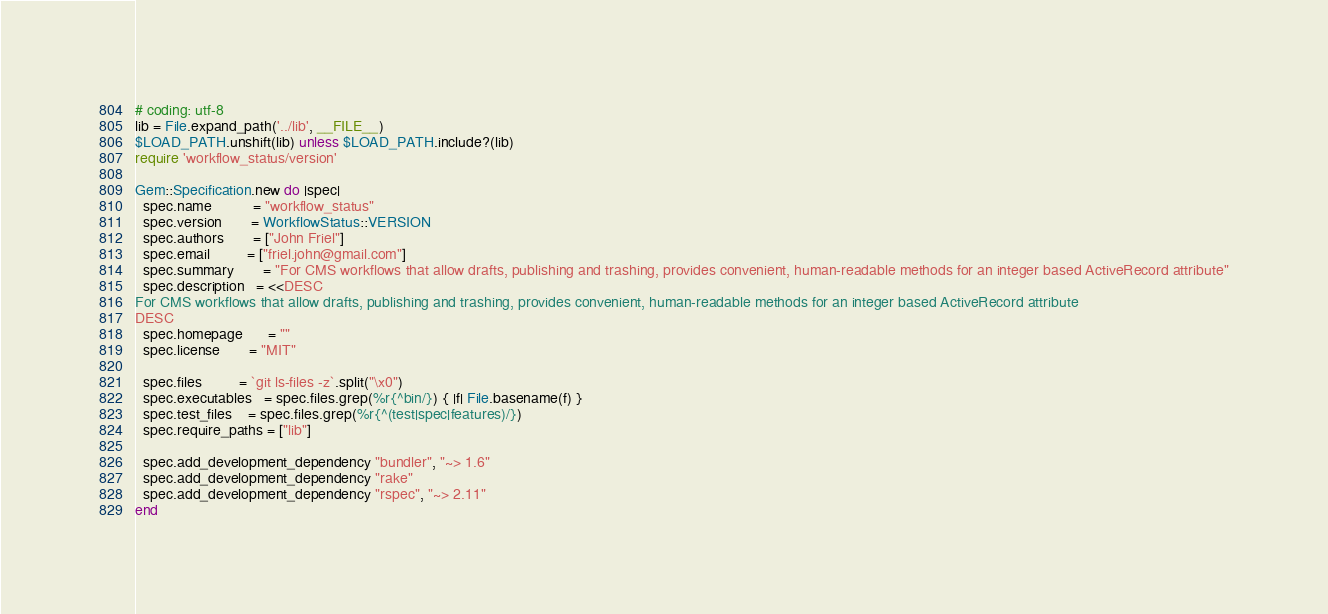<code> <loc_0><loc_0><loc_500><loc_500><_Ruby_># coding: utf-8
lib = File.expand_path('../lib', __FILE__)
$LOAD_PATH.unshift(lib) unless $LOAD_PATH.include?(lib)
require 'workflow_status/version'

Gem::Specification.new do |spec|
  spec.name          = "workflow_status"
  spec.version       = WorkflowStatus::VERSION
  spec.authors       = ["John Friel"]
  spec.email         = ["friel.john@gmail.com"]
  spec.summary       = "For CMS workflows that allow drafts, publishing and trashing, provides convenient, human-readable methods for an integer based ActiveRecord attribute"
  spec.description   = <<DESC
For CMS workflows that allow drafts, publishing and trashing, provides convenient, human-readable methods for an integer based ActiveRecord attribute
DESC
  spec.homepage      = ""
  spec.license       = "MIT"

  spec.files         = `git ls-files -z`.split("\x0")
  spec.executables   = spec.files.grep(%r{^bin/}) { |f| File.basename(f) }
  spec.test_files    = spec.files.grep(%r{^(test|spec|features)/})
  spec.require_paths = ["lib"]

  spec.add_development_dependency "bundler", "~> 1.6"
  spec.add_development_dependency "rake"
  spec.add_development_dependency "rspec", "~> 2.11"
end
</code> 